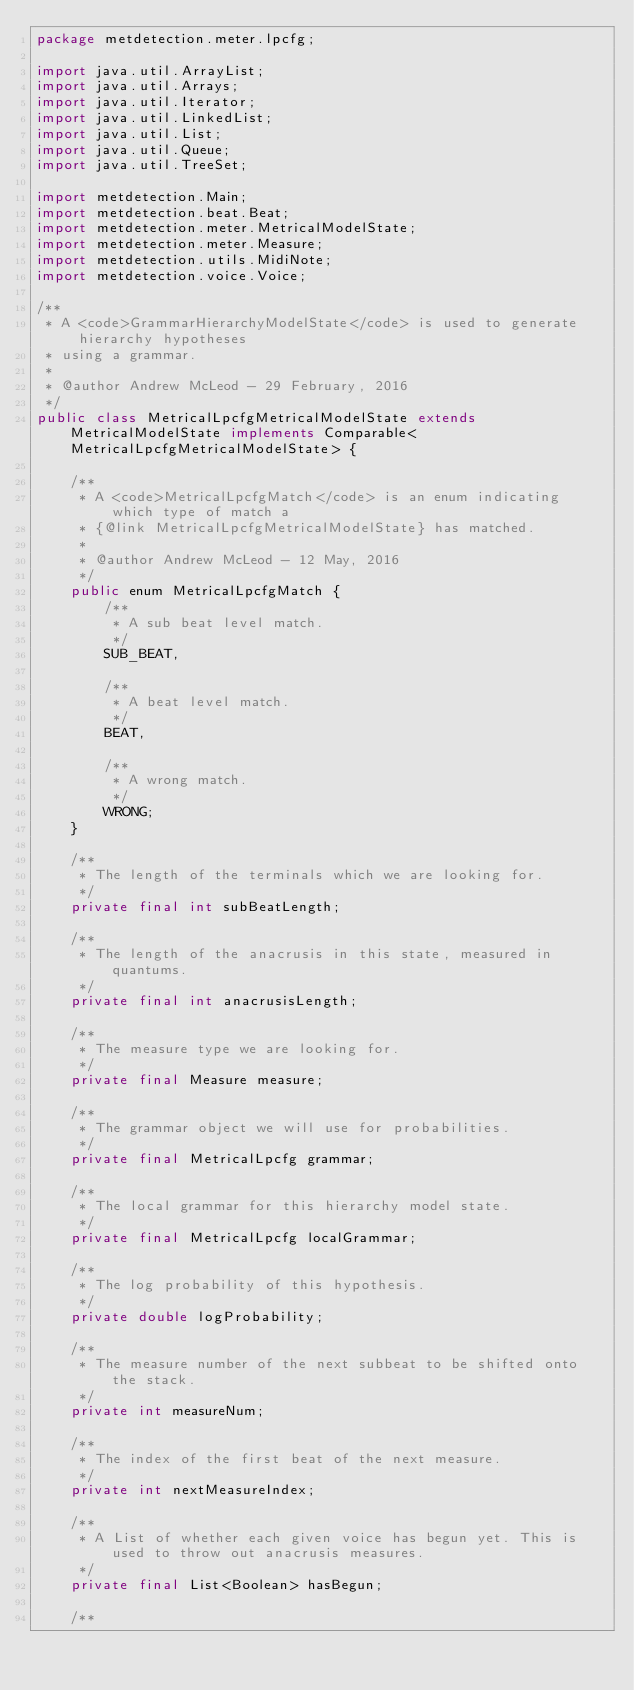Convert code to text. <code><loc_0><loc_0><loc_500><loc_500><_Java_>package metdetection.meter.lpcfg;

import java.util.ArrayList;
import java.util.Arrays;
import java.util.Iterator;
import java.util.LinkedList;
import java.util.List;
import java.util.Queue;
import java.util.TreeSet;

import metdetection.Main;
import metdetection.beat.Beat;
import metdetection.meter.MetricalModelState;
import metdetection.meter.Measure;
import metdetection.utils.MidiNote;
import metdetection.voice.Voice;

/**
 * A <code>GrammarHierarchyModelState</code> is used to generate hierarchy hypotheses
 * using a grammar.
 * 
 * @author Andrew McLeod - 29 February, 2016
 */
public class MetricalLpcfgMetricalModelState extends MetricalModelState implements Comparable<MetricalLpcfgMetricalModelState> {
	
	/**
	 * A <code>MetricalLpcfgMatch</code> is an enum indicating which type of match a
	 * {@link MetricalLpcfgMetricalModelState} has matched.
	 * 
	 * @author Andrew McLeod - 12 May, 2016
	 */
	public enum MetricalLpcfgMatch {
		/**
		 * A sub beat level match.
		 */
		SUB_BEAT,
		
		/**
		 * A beat level match.
		 */
		BEAT,
		
		/**
		 * A wrong match.
		 */
		WRONG;
	}

	/**
	 * The length of the terminals which we are looking for.
	 */
	private final int subBeatLength;
	
	/**
	 * The length of the anacrusis in this state, measured in quantums.
	 */
	private final int anacrusisLength;
	
	/**
	 * The measure type we are looking for.
	 */
	private final Measure measure;
	
	/**
	 * The grammar object we will use for probabilities.
	 */
	private final MetricalLpcfg grammar;
	
	/**
	 * The local grammar for this hierarchy model state.
	 */
	private final MetricalLpcfg localGrammar;
	
	/**
	 * The log probability of this hypothesis.
	 */
	private double logProbability;
	
	/**
	 * The measure number of the next subbeat to be shifted onto the stack.
	 */
	private int measureNum;
	
	/**
	 * The index of the first beat of the next measure.
	 */
	private int nextMeasureIndex;
	
	/**
	 * A List of whether each given voice has begun yet. This is used to throw out anacrusis measures.
	 */
	private final List<Boolean> hasBegun;
	
	/**</code> 